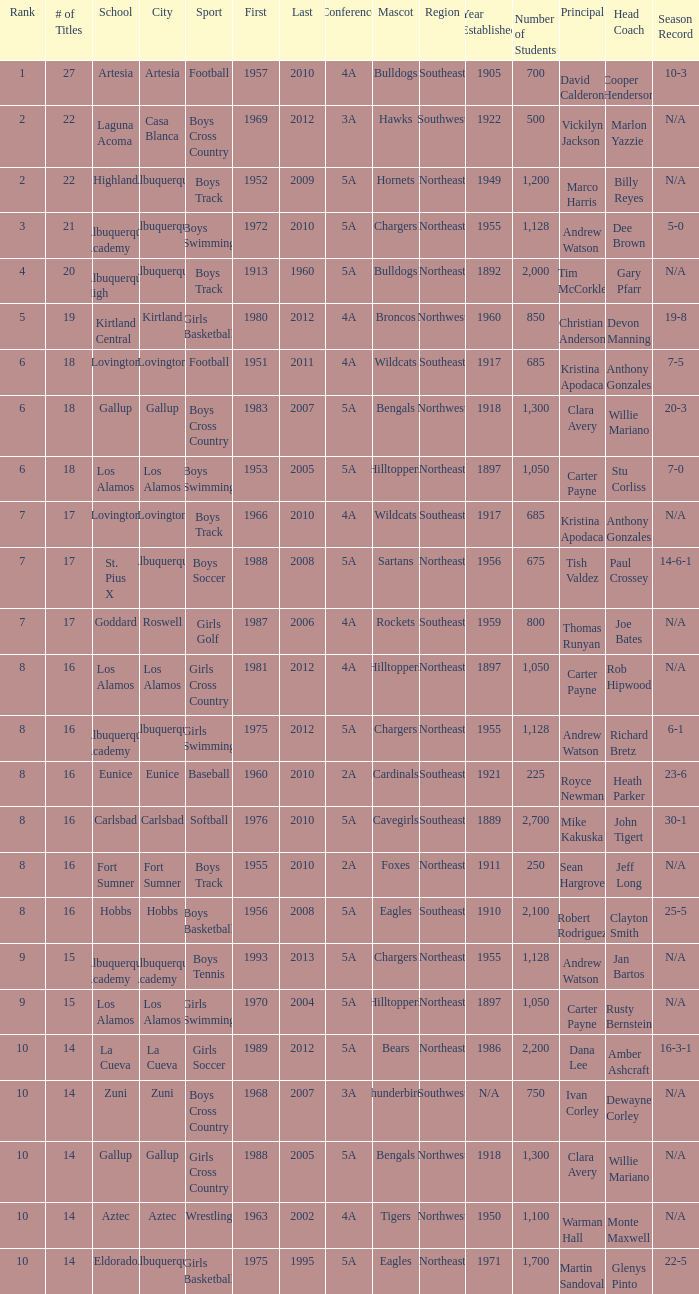What city is the school that had less than 17 titles in boys basketball with the last title being after 2005? Hobbs. 